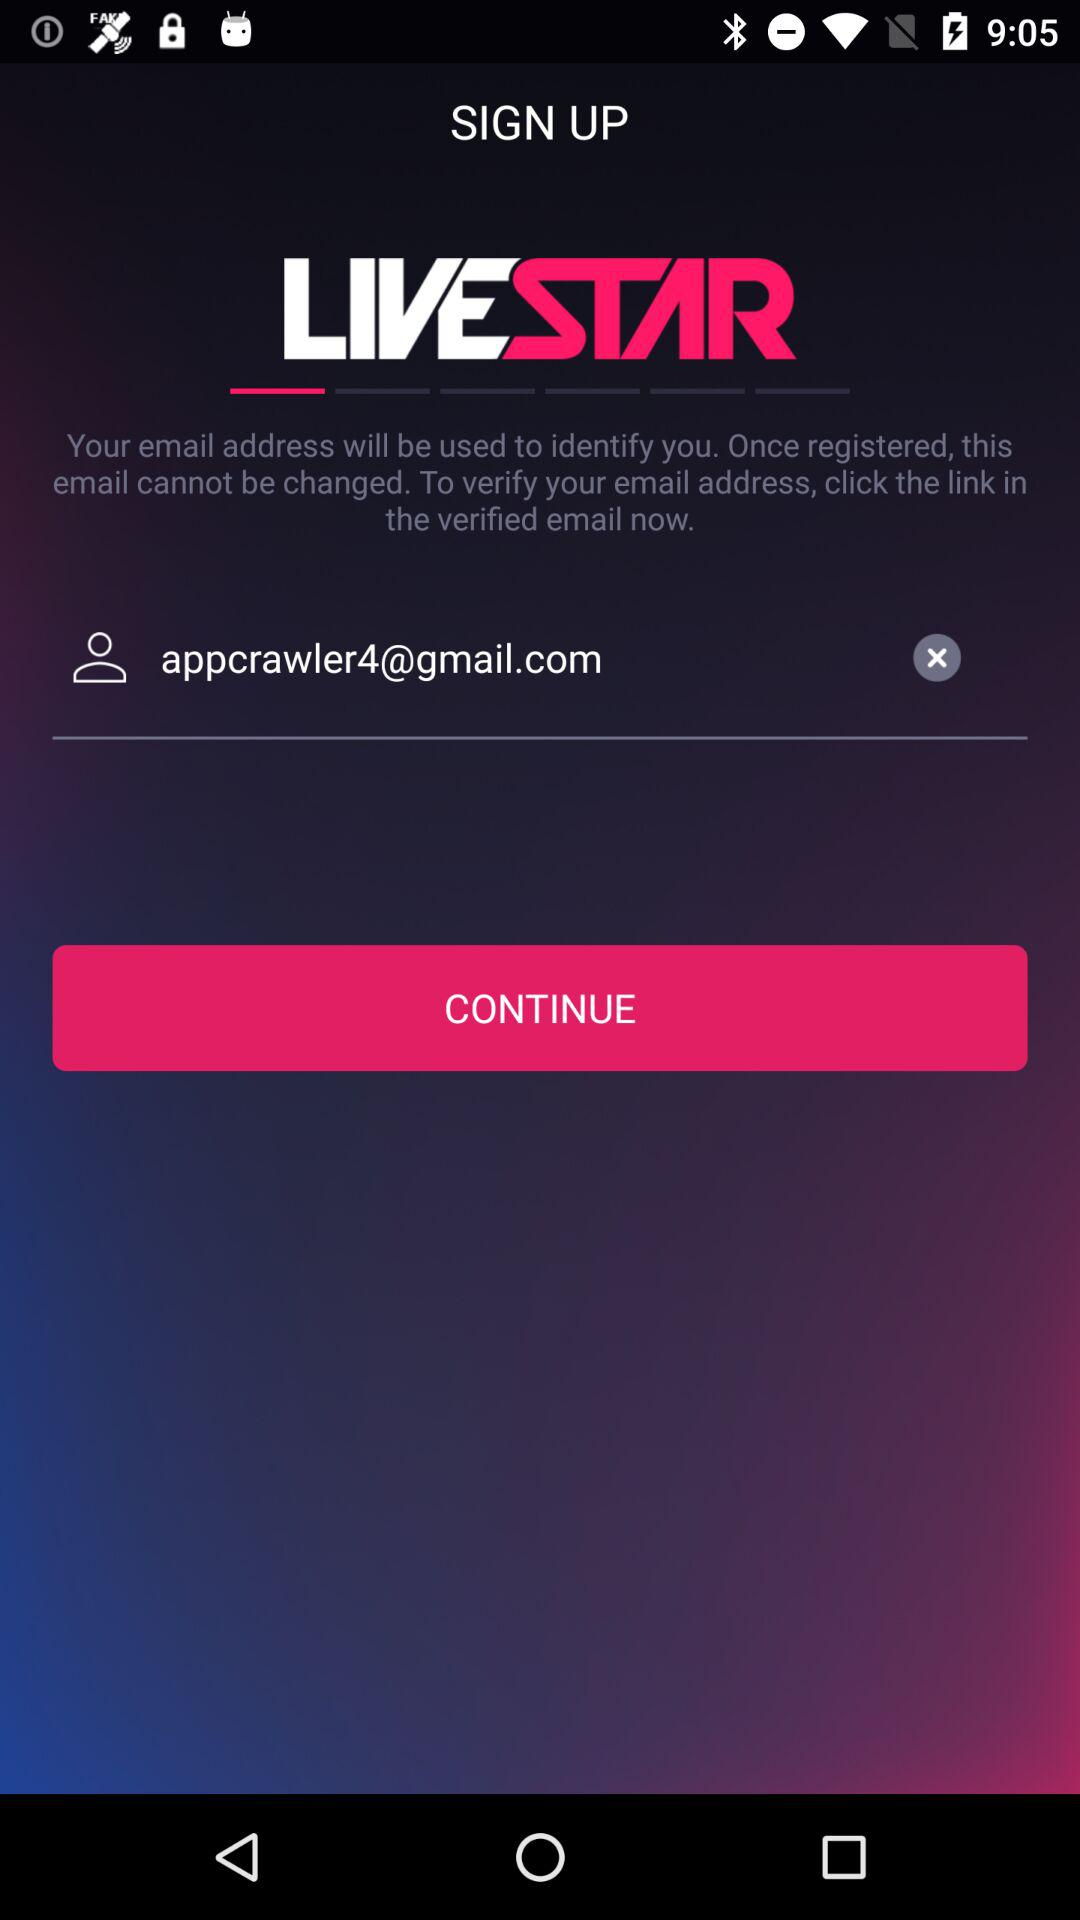What's the Google mail address? The Google mail address is appcrawler4@gmail.com. 